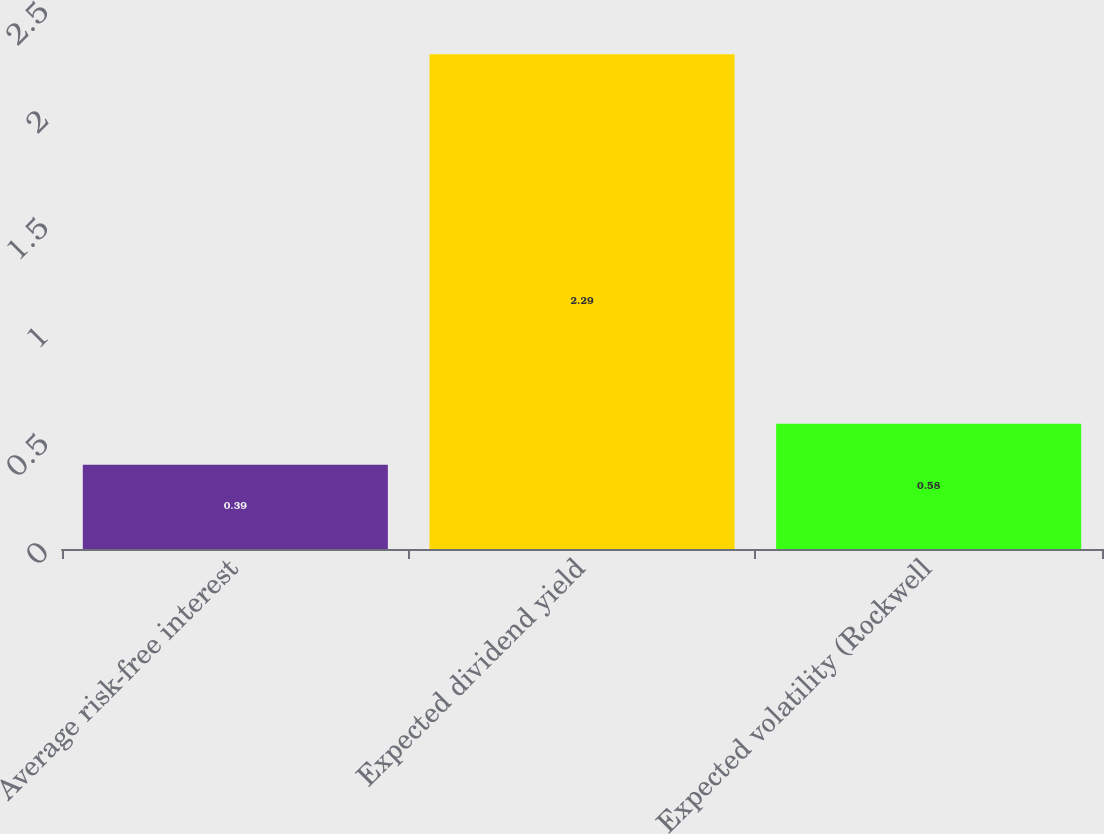<chart> <loc_0><loc_0><loc_500><loc_500><bar_chart><fcel>Average risk-free interest<fcel>Expected dividend yield<fcel>Expected volatility (Rockwell<nl><fcel>0.39<fcel>2.29<fcel>0.58<nl></chart> 